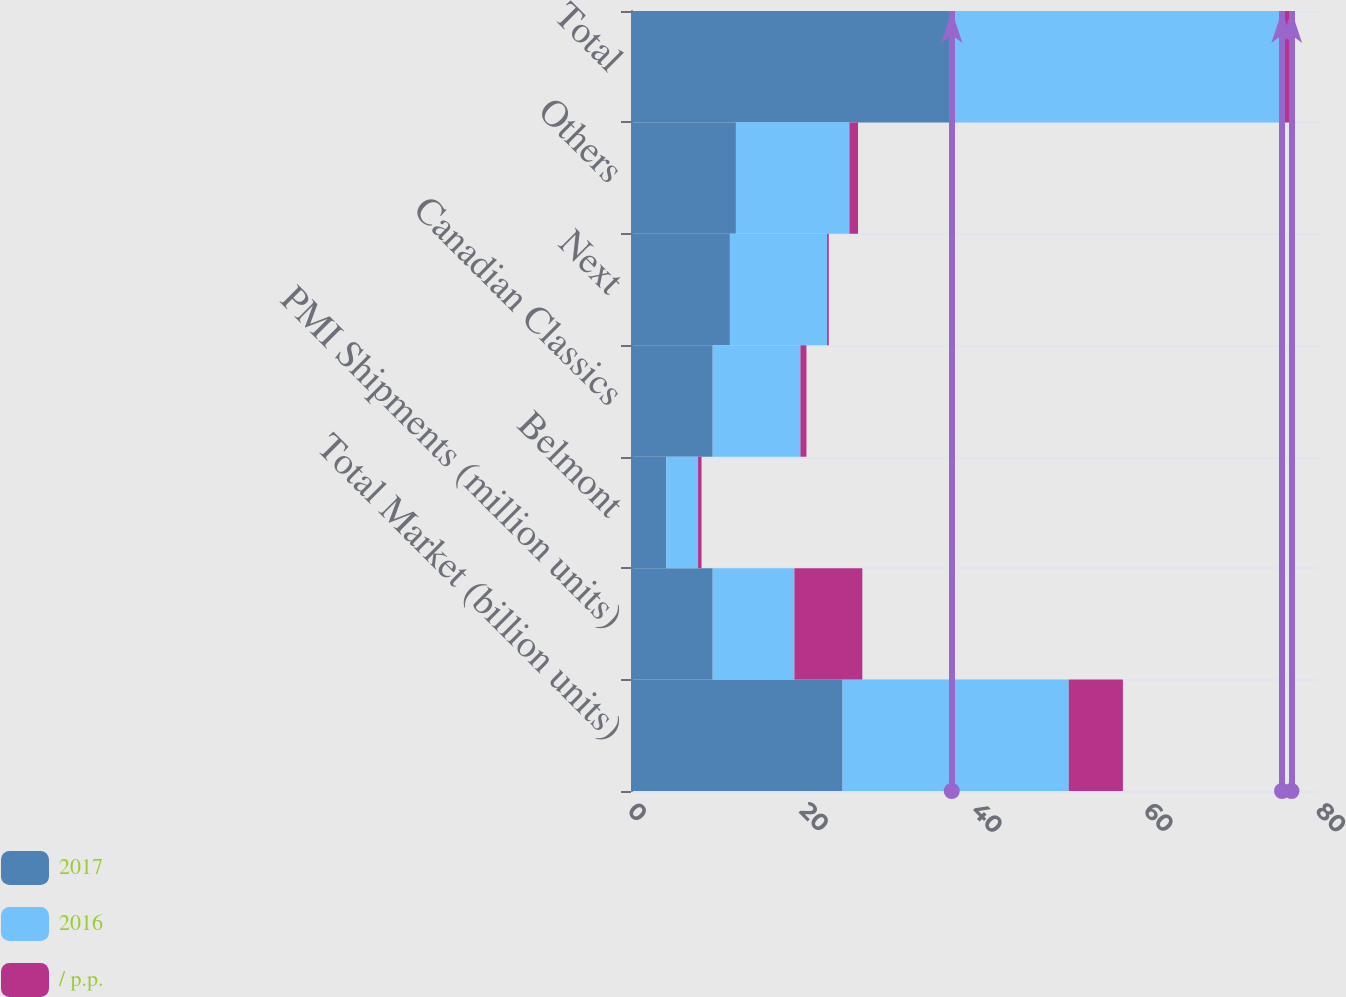<chart> <loc_0><loc_0><loc_500><loc_500><stacked_bar_chart><ecel><fcel>Total Market (billion units)<fcel>PMI Shipments (million units)<fcel>Belmont<fcel>Canadian Classics<fcel>Next<fcel>Others<fcel>Total<nl><fcel>2017<fcel>24.6<fcel>9.5<fcel>4.1<fcel>9.5<fcel>11.5<fcel>12.2<fcel>37.3<nl><fcel>2016<fcel>26.3<fcel>9.5<fcel>3.7<fcel>10.2<fcel>11.3<fcel>13.2<fcel>38.4<nl><fcel>/ p.p.<fcel>6.3<fcel>7.9<fcel>0.4<fcel>0.7<fcel>0.2<fcel>1<fcel>1.1<nl></chart> 